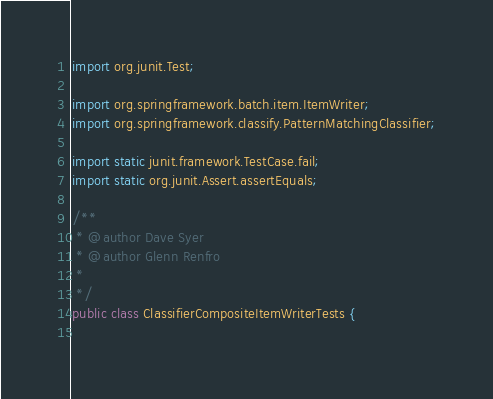Convert code to text. <code><loc_0><loc_0><loc_500><loc_500><_Java_>import org.junit.Test;

import org.springframework.batch.item.ItemWriter;
import org.springframework.classify.PatternMatchingClassifier;

import static junit.framework.TestCase.fail;
import static org.junit.Assert.assertEquals;

/**
 * @author Dave Syer
 * @author Glenn Renfro
 *
 */
public class ClassifierCompositeItemWriterTests {
	</code> 